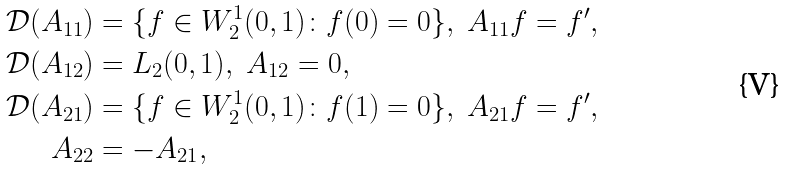<formula> <loc_0><loc_0><loc_500><loc_500>\mathcal { D } ( A _ { 1 1 } ) & = \{ f \in W _ { 2 } ^ { 1 } ( 0 , 1 ) \colon f ( 0 ) = 0 \} , \ A _ { 1 1 } f = f ^ { \prime } , \\ \mathcal { D } ( A _ { 1 2 } ) & = L _ { 2 } ( 0 , 1 ) , \ A _ { 1 2 } = 0 , \\ \mathcal { D } ( A _ { 2 1 } ) & = \{ f \in W _ { 2 } ^ { 1 } ( 0 , 1 ) \colon f ( 1 ) = 0 \} , \ A _ { 2 1 } f = f ^ { \prime } , \\ A _ { 2 2 } & = - A _ { 2 1 } ,</formula> 